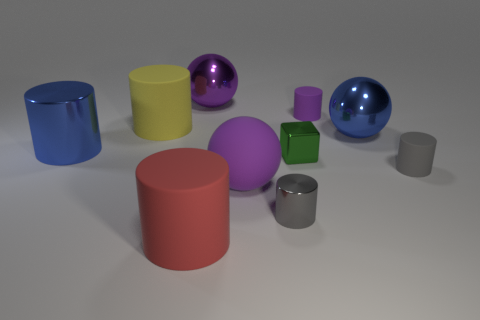Can you tell me what the largest object in the image is and what it might be used for? The largest object in the image is the blue cylinder on the left. Given its simple geometric shape, it may be used for educational purposes, like teaching about volumes and areas, or as a placeholder in a graphics rendering test. 